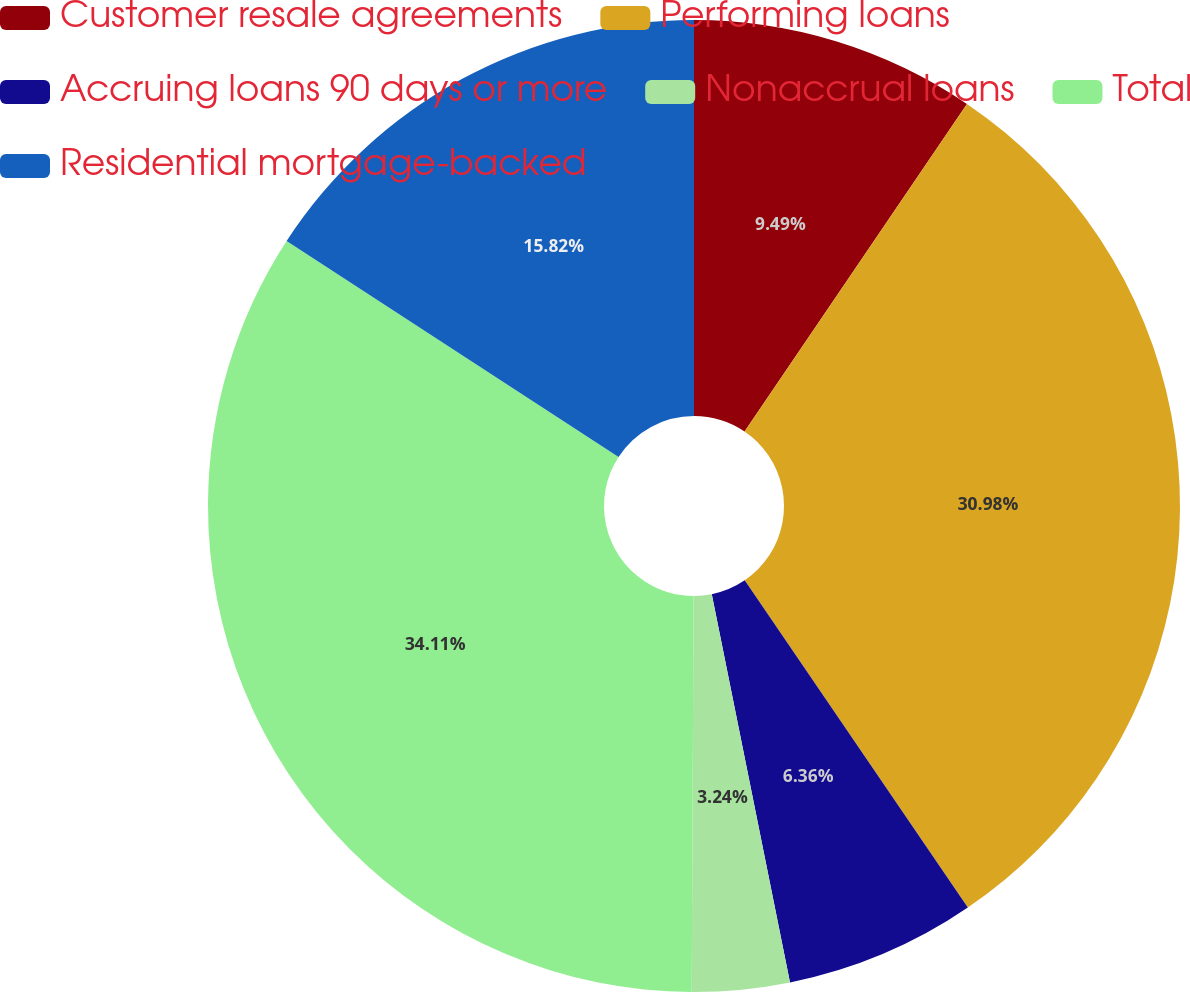<chart> <loc_0><loc_0><loc_500><loc_500><pie_chart><fcel>Customer resale agreements<fcel>Performing loans<fcel>Accruing loans 90 days or more<fcel>Nonaccrual loans<fcel>Total<fcel>Residential mortgage-backed<nl><fcel>9.49%<fcel>30.98%<fcel>6.36%<fcel>3.24%<fcel>34.1%<fcel>15.82%<nl></chart> 